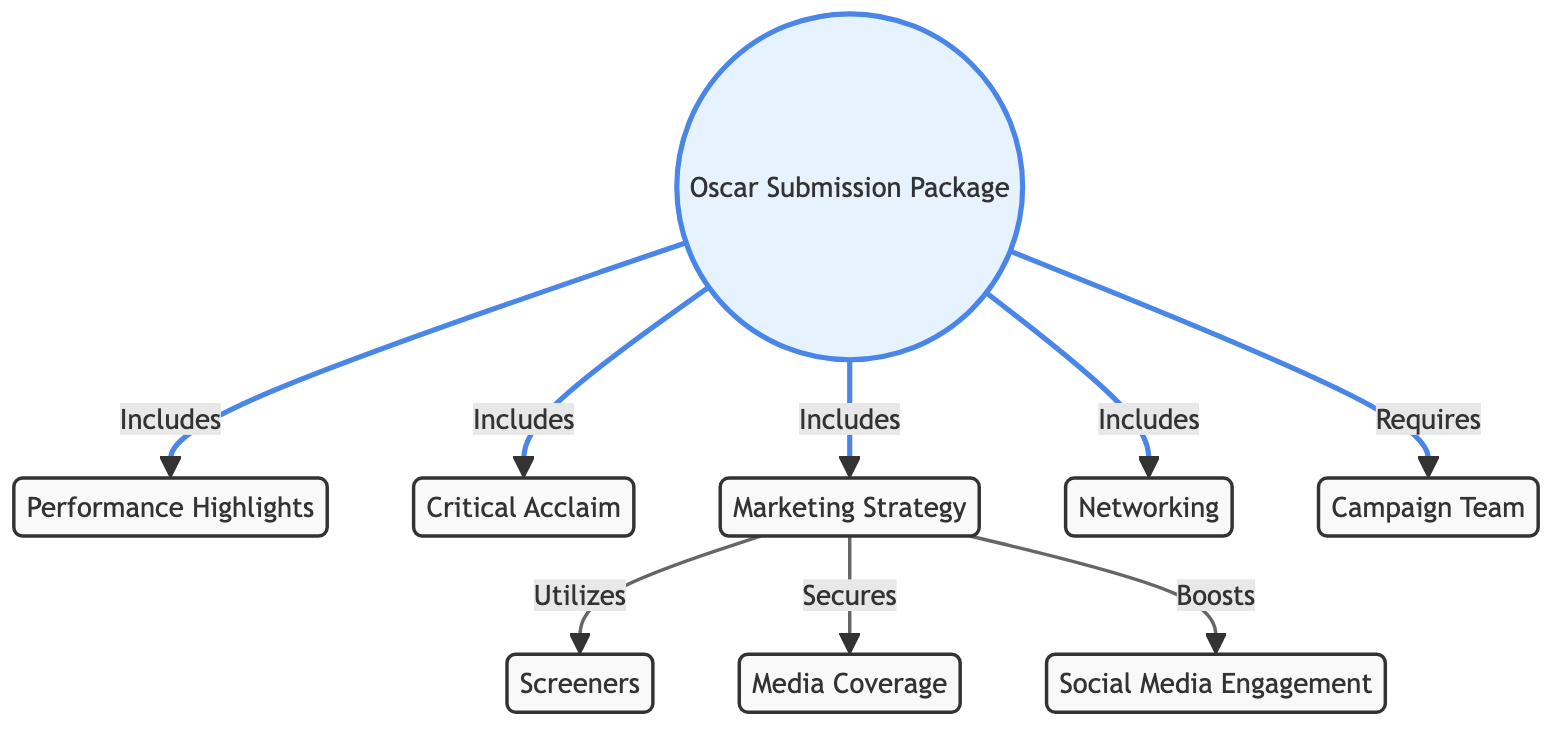What is included in the Oscar Submission Package? The Oscar Submission Package includes multiple elements, specifically connected nodes: Performance Highlights, Critical Acclaim, Marketing Strategy, and Networking. These connections suggest they are essential components of the package.
Answer: Performance Highlights, Critical Acclaim, Marketing Strategy, Networking How many elements are required for the Oscar Submission Package? The diagram shows one direct connection labeled "Requires" from the Oscar Submission Package to the Campaign Team, indicating that there is one required element for the submission package.
Answer: 1 What strategy is utilized to enhance screeners? The Marketing Strategy node is linked to the Screeners node with the connection "Utilizes," suggesting that the marketing strategy actively employs screeners as part of its approach.
Answer: Utilizes Which aspect of the Marketing Strategy boosts public engagement? The diagram indicates that the Marketing Strategy boosts Social Media Engagement, as indicated by the connection labeled "Boosts" between these two nodes. This demonstrates how marketing efforts are directed towards enhancing social media presence.
Answer: Boosts How many nodes are connected to the Oscar Submission Package? The Oscar Submission Package has three direct connections labeled "Includes" and one labeled "Requires," making a total of four connected nodes (Performance Highlights, Critical Acclaim, Marketing Strategy, Networking) plus one requirement (Campaign Team). Therefore, there are five in total when the package is considered.
Answer: 5 What type of coverage is secured through the Marketing Strategy? The Marketing Strategy is directly linked to Media Coverage, indicated by the term "Secures." This implies that securing media coverage is a key action of the marketing strategy and is crucial for the campaign’s success.
Answer: Secures What does the Campaign Team contribute to the Oscar Submission Package? The Campaign Team is required for the Oscar Submission Package, indicated by the connection labeled "Requires." This shows that a dedicated campaign team is essential to compile and present the package effectively.
Answer: Requires How does the Marketing Strategy influence media relations? The diagram specifies that the Marketing Strategy "Secures" Media Coverage, indicating that an effective marketing approach directly influences the media's involvement and coverage of the Oscar submission, thereby enhancing visibility.
Answer: Secures 